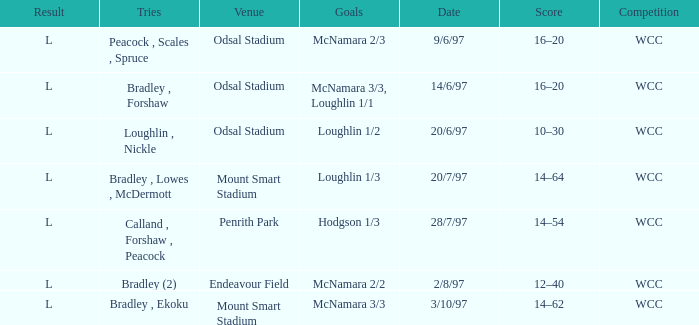What was the score on 20/6/97? 10–30. 